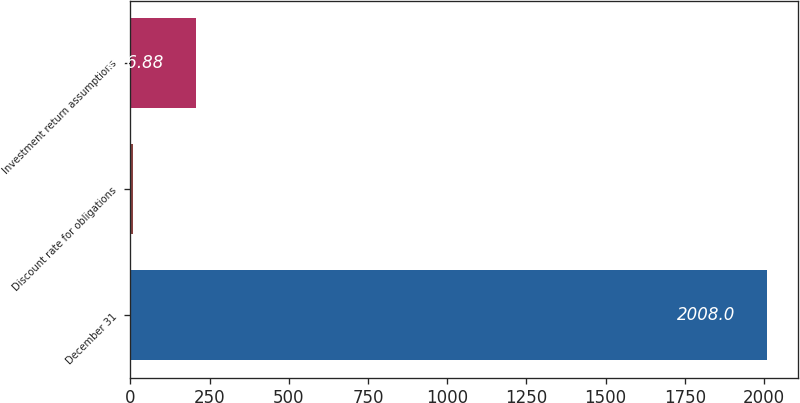Convert chart. <chart><loc_0><loc_0><loc_500><loc_500><bar_chart><fcel>December 31<fcel>Discount rate for obligations<fcel>Investment return assumptions<nl><fcel>2008<fcel>6.75<fcel>206.88<nl></chart> 